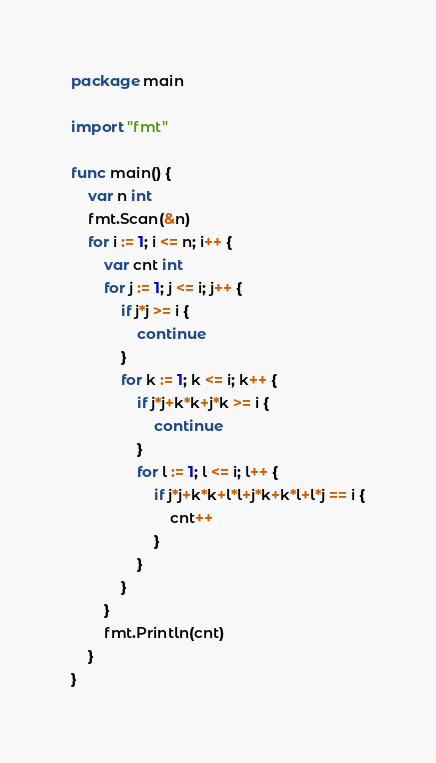Convert code to text. <code><loc_0><loc_0><loc_500><loc_500><_Go_>package main

import "fmt"

func main() {
	var n int
	fmt.Scan(&n)
	for i := 1; i <= n; i++ {
		var cnt int
		for j := 1; j <= i; j++ {
			if j*j >= i {
				continue
			}
			for k := 1; k <= i; k++ {
				if j*j+k*k+j*k >= i {
					continue
				}
				for l := 1; l <= i; l++ {
					if j*j+k*k+l*l+j*k+k*l+l*j == i {
						cnt++
					}
				}
			}
		}
		fmt.Println(cnt)
	}
}
</code> 